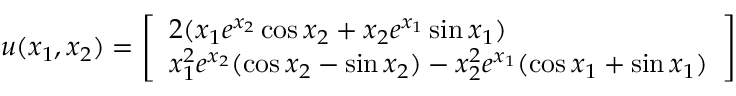Convert formula to latex. <formula><loc_0><loc_0><loc_500><loc_500>\begin{array} { r } { u ( x _ { 1 } , x _ { 2 } ) = \left [ \begin{array} { l } { 2 ( x _ { 1 } e ^ { x _ { 2 } } \cos x _ { 2 } + x _ { 2 } e ^ { x _ { 1 } } \sin x _ { 1 } ) } \\ { x _ { 1 } ^ { 2 } e ^ { x _ { 2 } } ( \cos x _ { 2 } - \sin x _ { 2 } ) - x _ { 2 } ^ { 2 } e ^ { x _ { 1 } } ( \cos x _ { 1 } + \sin x _ { 1 } ) } \end{array} \right ] } \end{array}</formula> 